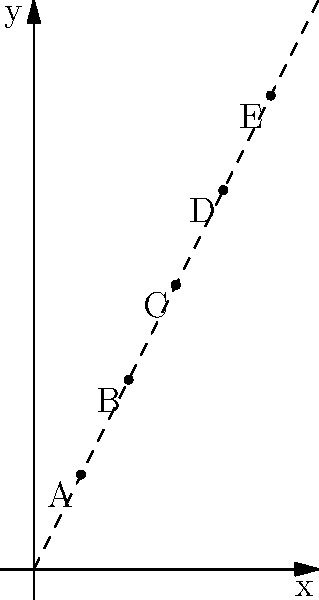In a cryptographic system, the distribution of encryption keys follows a linear pattern in a 2D coordinate system. The graph shows five points (A, B, C, D, E) representing key distributions. Given this pattern, what would be the y-coordinate of a point F with an x-coordinate of 6? To solve this problem, we need to follow these steps:

1. Observe the pattern in the given points:
   A(1,2), B(2,4), C(3,6), D(4,8), E(5,10)

2. Recognize that this is a linear pattern where:
   $y = 2x$ for all points

3. We can confirm this by checking any point, e.g., for C(3,6):
   $y = 2 * 3 = 6$

4. Now, for point F with x-coordinate 6, we can use the same formula:
   $y = 2x$
   $y = 2 * 6 = 12$

5. Therefore, the y-coordinate of point F would be 12.

This linear pattern in key distribution could represent a simple key derivation function where each subsequent key is generated by doubling the previous one. In a real-world scenario, such a predictable pattern would be vulnerable to attacks, highlighting the importance of using more complex and random key generation methods in cryptographic systems.
Answer: 12 